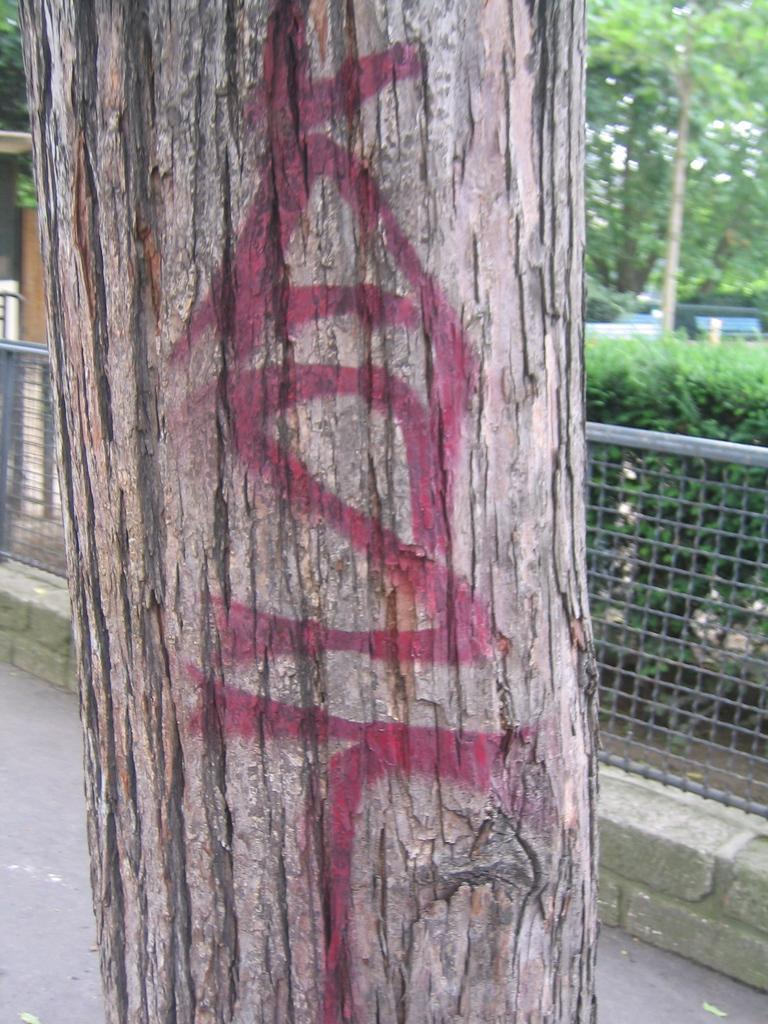What type of natural material is present in the image? There is tree bark in the image. What type of structure can be seen in the image? There is fencing in the image. What type of vegetation is present in the image? There are trees and plants in the image. What type of man-made structure is present in the image? There is a road in the image. What type of humor can be seen in the image? There is no humor present in the image; it is a photograph of natural and man-made elements. Can you see a kite flying in the image? There is no kite present in the image. 